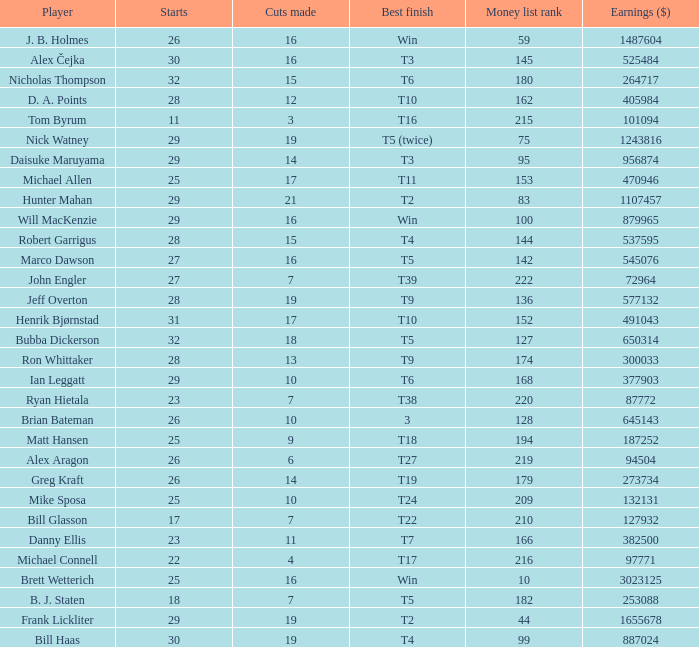What is the peak money list placement for matt hansen? 194.0. 